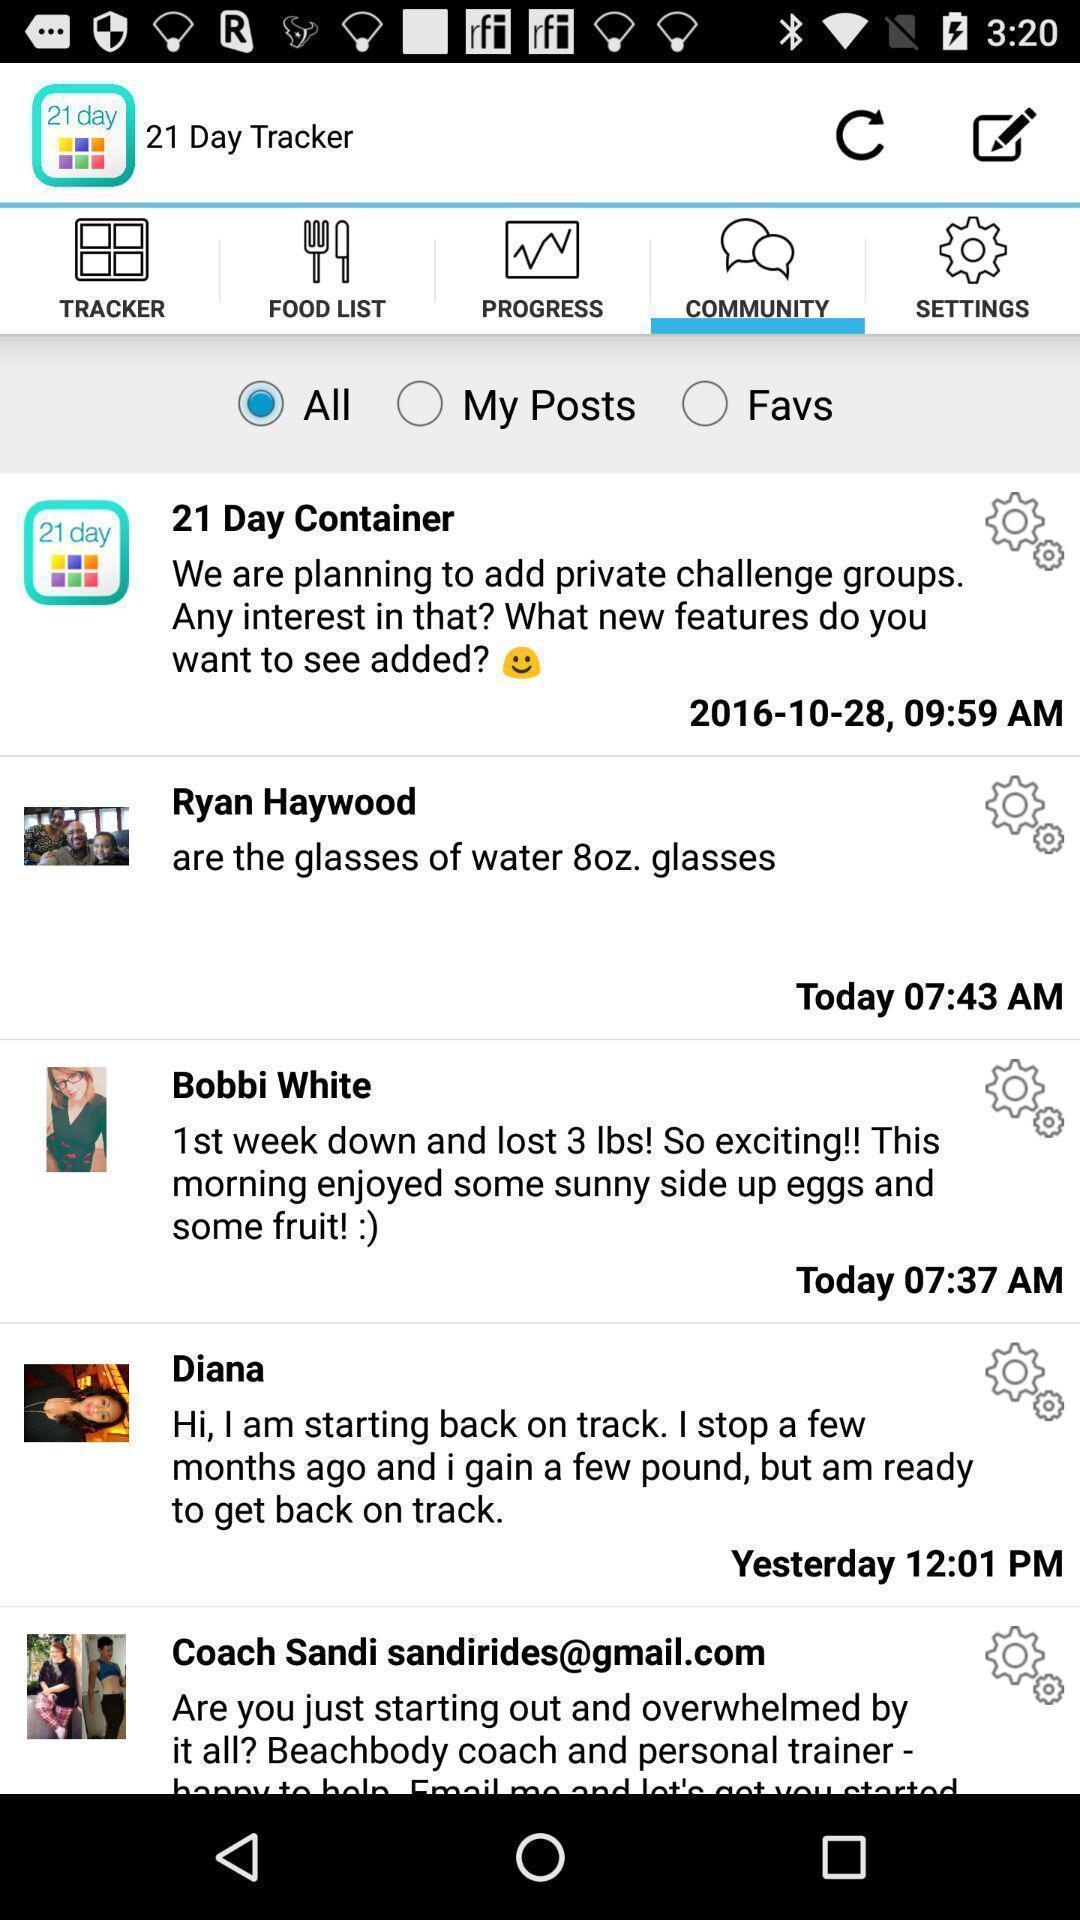What is the overall content of this screenshot? Page shows post 's with options. 